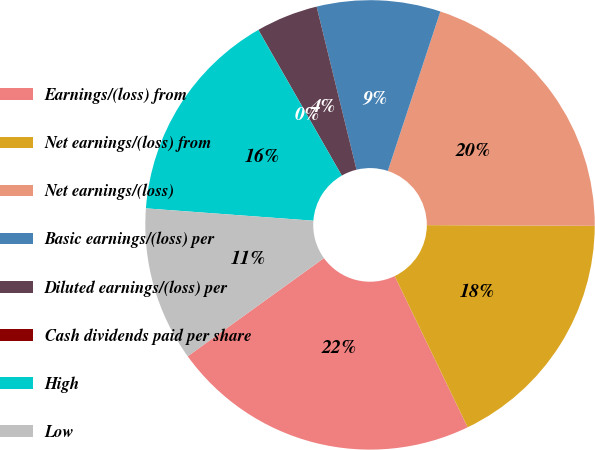Convert chart. <chart><loc_0><loc_0><loc_500><loc_500><pie_chart><fcel>Earnings/(loss) from<fcel>Net earnings/(loss) from<fcel>Net earnings/(loss)<fcel>Basic earnings/(loss) per<fcel>Diluted earnings/(loss) per<fcel>Cash dividends paid per share<fcel>High<fcel>Low<nl><fcel>22.22%<fcel>17.78%<fcel>20.0%<fcel>8.89%<fcel>4.45%<fcel>0.01%<fcel>15.55%<fcel>11.11%<nl></chart> 